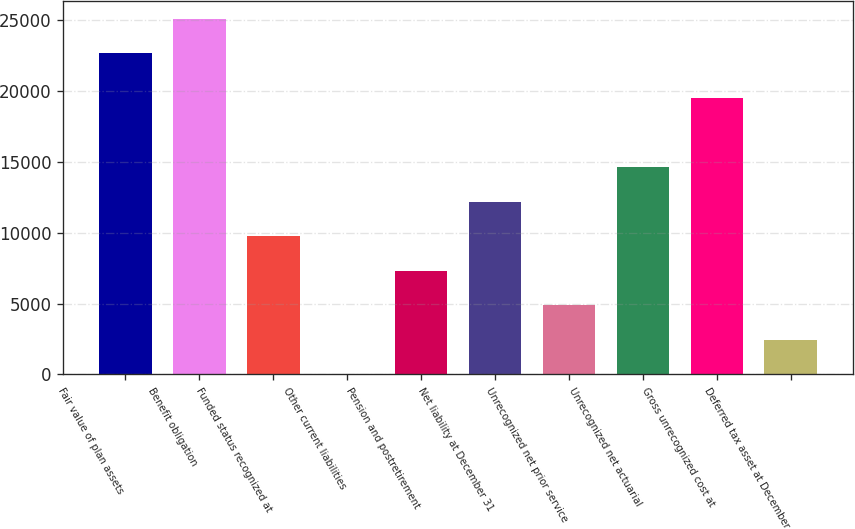Convert chart to OTSL. <chart><loc_0><loc_0><loc_500><loc_500><bar_chart><fcel>Fair value of plan assets<fcel>Benefit obligation<fcel>Funded status recognized at<fcel>Other current liabilities<fcel>Pension and postretirement<fcel>Net liability at December 31<fcel>Unrecognized net prior service<fcel>Unrecognized net actuarial<fcel>Gross unrecognized cost at<fcel>Deferred tax asset at December<nl><fcel>22663<fcel>25100.3<fcel>9762.2<fcel>13<fcel>7324.9<fcel>12199.5<fcel>4887.6<fcel>14636.8<fcel>19511.4<fcel>2450.3<nl></chart> 